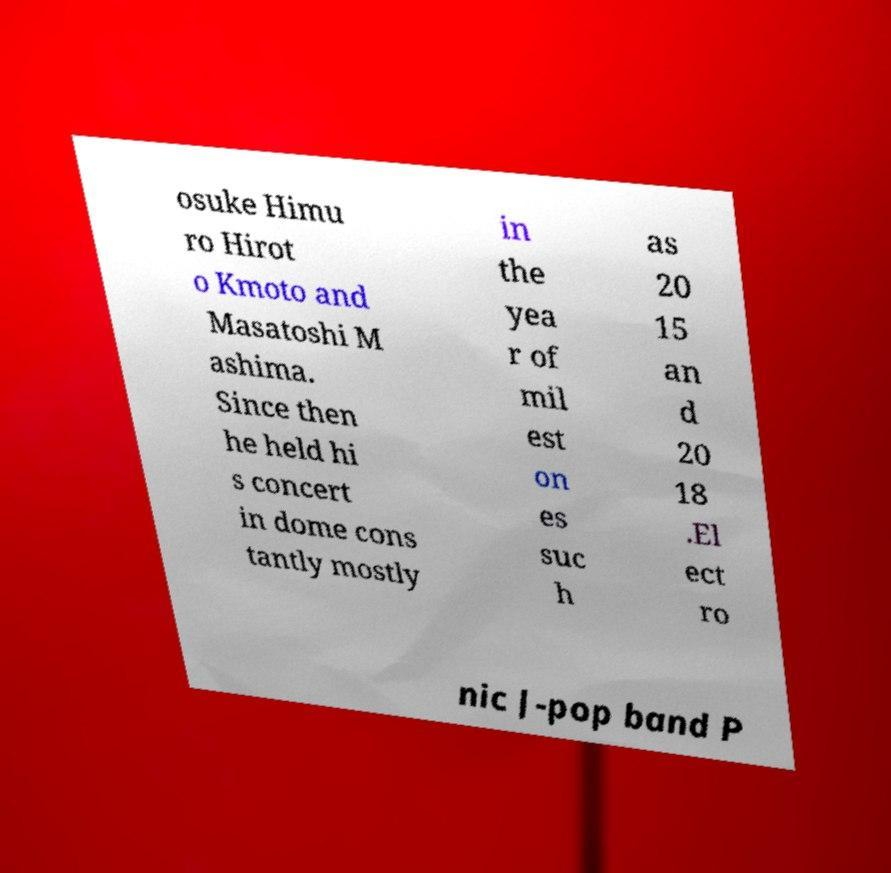What messages or text are displayed in this image? I need them in a readable, typed format. osuke Himu ro Hirot o Kmoto and Masatoshi M ashima. Since then he held hi s concert in dome cons tantly mostly in the yea r of mil est on es suc h as 20 15 an d 20 18 .El ect ro nic J-pop band P 